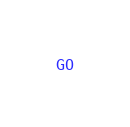<code> <loc_0><loc_0><loc_500><loc_500><_SQL_>GO</code> 